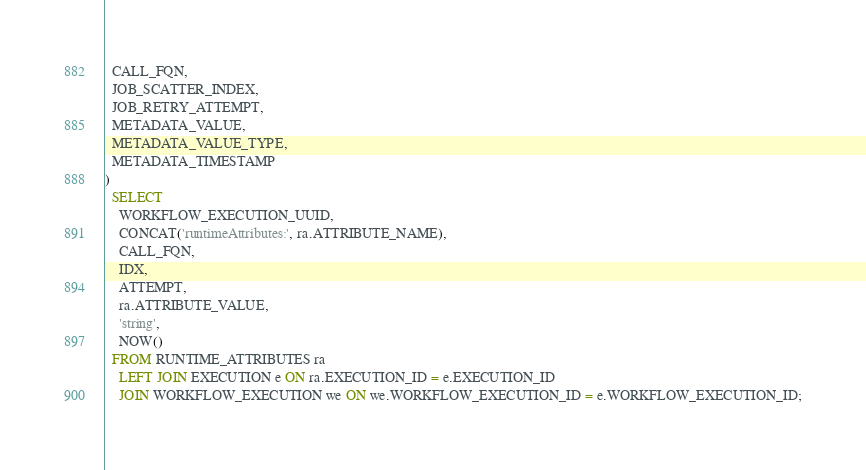<code> <loc_0><loc_0><loc_500><loc_500><_SQL_>  CALL_FQN,
  JOB_SCATTER_INDEX,
  JOB_RETRY_ATTEMPT,
  METADATA_VALUE,
  METADATA_VALUE_TYPE,
  METADATA_TIMESTAMP
)
  SELECT
    WORKFLOW_EXECUTION_UUID,
    CONCAT('runtimeAttributes:', ra.ATTRIBUTE_NAME),
    CALL_FQN,
    IDX,
    ATTEMPT,
    ra.ATTRIBUTE_VALUE,
    'string',
    NOW()
  FROM RUNTIME_ATTRIBUTES ra
    LEFT JOIN EXECUTION e ON ra.EXECUTION_ID = e.EXECUTION_ID
    JOIN WORKFLOW_EXECUTION we ON we.WORKFLOW_EXECUTION_ID = e.WORKFLOW_EXECUTION_ID;
</code> 